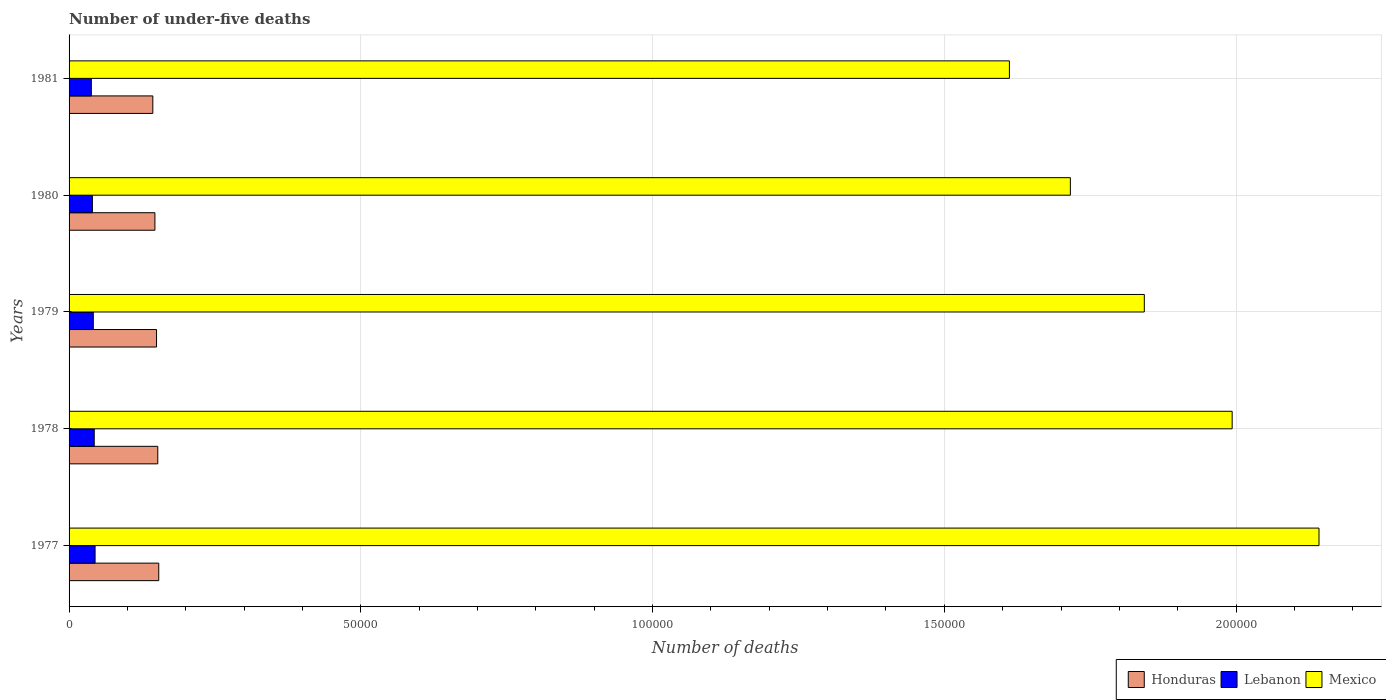How many groups of bars are there?
Your answer should be very brief. 5. Are the number of bars on each tick of the Y-axis equal?
Keep it short and to the point. Yes. How many bars are there on the 4th tick from the top?
Your answer should be compact. 3. In how many cases, is the number of bars for a given year not equal to the number of legend labels?
Offer a very short reply. 0. What is the number of under-five deaths in Lebanon in 1978?
Ensure brevity in your answer.  4313. Across all years, what is the maximum number of under-five deaths in Lebanon?
Keep it short and to the point. 4458. Across all years, what is the minimum number of under-five deaths in Lebanon?
Offer a very short reply. 3815. In which year was the number of under-five deaths in Mexico maximum?
Ensure brevity in your answer.  1977. In which year was the number of under-five deaths in Mexico minimum?
Offer a terse response. 1981. What is the total number of under-five deaths in Mexico in the graph?
Provide a succinct answer. 9.31e+05. What is the difference between the number of under-five deaths in Honduras in 1978 and that in 1980?
Provide a succinct answer. 490. What is the difference between the number of under-five deaths in Mexico in 1980 and the number of under-five deaths in Lebanon in 1979?
Your response must be concise. 1.67e+05. What is the average number of under-five deaths in Honduras per year?
Ensure brevity in your answer.  1.49e+04. In the year 1977, what is the difference between the number of under-five deaths in Lebanon and number of under-five deaths in Honduras?
Provide a short and direct response. -1.09e+04. What is the ratio of the number of under-five deaths in Lebanon in 1978 to that in 1979?
Ensure brevity in your answer.  1.04. Is the number of under-five deaths in Mexico in 1978 less than that in 1979?
Your answer should be very brief. No. Is the difference between the number of under-five deaths in Lebanon in 1978 and 1979 greater than the difference between the number of under-five deaths in Honduras in 1978 and 1979?
Offer a very short reply. No. What is the difference between the highest and the second highest number of under-five deaths in Lebanon?
Provide a succinct answer. 145. What is the difference between the highest and the lowest number of under-five deaths in Mexico?
Your answer should be very brief. 5.31e+04. In how many years, is the number of under-five deaths in Lebanon greater than the average number of under-five deaths in Lebanon taken over all years?
Your response must be concise. 3. Is the sum of the number of under-five deaths in Honduras in 1977 and 1978 greater than the maximum number of under-five deaths in Lebanon across all years?
Your answer should be compact. Yes. What does the 3rd bar from the top in 1979 represents?
Your answer should be very brief. Honduras. How many bars are there?
Ensure brevity in your answer.  15. Are all the bars in the graph horizontal?
Offer a very short reply. Yes. How many years are there in the graph?
Provide a succinct answer. 5. What is the difference between two consecutive major ticks on the X-axis?
Your answer should be compact. 5.00e+04. Does the graph contain any zero values?
Make the answer very short. No. Does the graph contain grids?
Keep it short and to the point. Yes. How many legend labels are there?
Your answer should be very brief. 3. What is the title of the graph?
Offer a terse response. Number of under-five deaths. What is the label or title of the X-axis?
Keep it short and to the point. Number of deaths. What is the Number of deaths of Honduras in 1977?
Your answer should be very brief. 1.54e+04. What is the Number of deaths of Lebanon in 1977?
Provide a short and direct response. 4458. What is the Number of deaths of Mexico in 1977?
Offer a terse response. 2.14e+05. What is the Number of deaths in Honduras in 1978?
Provide a succinct answer. 1.52e+04. What is the Number of deaths of Lebanon in 1978?
Your answer should be compact. 4313. What is the Number of deaths of Mexico in 1978?
Your answer should be compact. 1.99e+05. What is the Number of deaths of Honduras in 1979?
Keep it short and to the point. 1.50e+04. What is the Number of deaths in Lebanon in 1979?
Your response must be concise. 4152. What is the Number of deaths in Mexico in 1979?
Your answer should be very brief. 1.84e+05. What is the Number of deaths of Honduras in 1980?
Provide a succinct answer. 1.47e+04. What is the Number of deaths in Lebanon in 1980?
Offer a terse response. 3993. What is the Number of deaths of Mexico in 1980?
Ensure brevity in your answer.  1.72e+05. What is the Number of deaths in Honduras in 1981?
Offer a terse response. 1.44e+04. What is the Number of deaths in Lebanon in 1981?
Make the answer very short. 3815. What is the Number of deaths of Mexico in 1981?
Your answer should be compact. 1.61e+05. Across all years, what is the maximum Number of deaths in Honduras?
Provide a succinct answer. 1.54e+04. Across all years, what is the maximum Number of deaths of Lebanon?
Ensure brevity in your answer.  4458. Across all years, what is the maximum Number of deaths of Mexico?
Ensure brevity in your answer.  2.14e+05. Across all years, what is the minimum Number of deaths of Honduras?
Give a very brief answer. 1.44e+04. Across all years, what is the minimum Number of deaths in Lebanon?
Give a very brief answer. 3815. Across all years, what is the minimum Number of deaths of Mexico?
Provide a succinct answer. 1.61e+05. What is the total Number of deaths in Honduras in the graph?
Offer a terse response. 7.46e+04. What is the total Number of deaths of Lebanon in the graph?
Your answer should be compact. 2.07e+04. What is the total Number of deaths in Mexico in the graph?
Your answer should be compact. 9.31e+05. What is the difference between the Number of deaths in Honduras in 1977 and that in 1978?
Offer a very short reply. 168. What is the difference between the Number of deaths of Lebanon in 1977 and that in 1978?
Keep it short and to the point. 145. What is the difference between the Number of deaths of Mexico in 1977 and that in 1978?
Your answer should be compact. 1.49e+04. What is the difference between the Number of deaths in Honduras in 1977 and that in 1979?
Make the answer very short. 379. What is the difference between the Number of deaths of Lebanon in 1977 and that in 1979?
Your answer should be very brief. 306. What is the difference between the Number of deaths in Mexico in 1977 and that in 1979?
Your response must be concise. 2.99e+04. What is the difference between the Number of deaths of Honduras in 1977 and that in 1980?
Offer a very short reply. 658. What is the difference between the Number of deaths in Lebanon in 1977 and that in 1980?
Offer a very short reply. 465. What is the difference between the Number of deaths in Mexico in 1977 and that in 1980?
Give a very brief answer. 4.26e+04. What is the difference between the Number of deaths in Honduras in 1977 and that in 1981?
Keep it short and to the point. 1016. What is the difference between the Number of deaths in Lebanon in 1977 and that in 1981?
Give a very brief answer. 643. What is the difference between the Number of deaths of Mexico in 1977 and that in 1981?
Your answer should be compact. 5.31e+04. What is the difference between the Number of deaths in Honduras in 1978 and that in 1979?
Your answer should be compact. 211. What is the difference between the Number of deaths of Lebanon in 1978 and that in 1979?
Your answer should be very brief. 161. What is the difference between the Number of deaths in Mexico in 1978 and that in 1979?
Keep it short and to the point. 1.51e+04. What is the difference between the Number of deaths of Honduras in 1978 and that in 1980?
Provide a short and direct response. 490. What is the difference between the Number of deaths in Lebanon in 1978 and that in 1980?
Offer a very short reply. 320. What is the difference between the Number of deaths of Mexico in 1978 and that in 1980?
Provide a short and direct response. 2.77e+04. What is the difference between the Number of deaths in Honduras in 1978 and that in 1981?
Offer a very short reply. 848. What is the difference between the Number of deaths of Lebanon in 1978 and that in 1981?
Offer a very short reply. 498. What is the difference between the Number of deaths of Mexico in 1978 and that in 1981?
Your response must be concise. 3.82e+04. What is the difference between the Number of deaths in Honduras in 1979 and that in 1980?
Your answer should be very brief. 279. What is the difference between the Number of deaths in Lebanon in 1979 and that in 1980?
Your answer should be very brief. 159. What is the difference between the Number of deaths in Mexico in 1979 and that in 1980?
Offer a terse response. 1.27e+04. What is the difference between the Number of deaths in Honduras in 1979 and that in 1981?
Ensure brevity in your answer.  637. What is the difference between the Number of deaths of Lebanon in 1979 and that in 1981?
Give a very brief answer. 337. What is the difference between the Number of deaths of Mexico in 1979 and that in 1981?
Offer a very short reply. 2.31e+04. What is the difference between the Number of deaths in Honduras in 1980 and that in 1981?
Offer a very short reply. 358. What is the difference between the Number of deaths in Lebanon in 1980 and that in 1981?
Keep it short and to the point. 178. What is the difference between the Number of deaths in Mexico in 1980 and that in 1981?
Keep it short and to the point. 1.04e+04. What is the difference between the Number of deaths of Honduras in 1977 and the Number of deaths of Lebanon in 1978?
Offer a very short reply. 1.11e+04. What is the difference between the Number of deaths of Honduras in 1977 and the Number of deaths of Mexico in 1978?
Provide a succinct answer. -1.84e+05. What is the difference between the Number of deaths of Lebanon in 1977 and the Number of deaths of Mexico in 1978?
Make the answer very short. -1.95e+05. What is the difference between the Number of deaths in Honduras in 1977 and the Number of deaths in Lebanon in 1979?
Make the answer very short. 1.12e+04. What is the difference between the Number of deaths of Honduras in 1977 and the Number of deaths of Mexico in 1979?
Offer a terse response. -1.69e+05. What is the difference between the Number of deaths in Lebanon in 1977 and the Number of deaths in Mexico in 1979?
Provide a short and direct response. -1.80e+05. What is the difference between the Number of deaths in Honduras in 1977 and the Number of deaths in Lebanon in 1980?
Offer a terse response. 1.14e+04. What is the difference between the Number of deaths in Honduras in 1977 and the Number of deaths in Mexico in 1980?
Make the answer very short. -1.56e+05. What is the difference between the Number of deaths in Lebanon in 1977 and the Number of deaths in Mexico in 1980?
Provide a succinct answer. -1.67e+05. What is the difference between the Number of deaths of Honduras in 1977 and the Number of deaths of Lebanon in 1981?
Offer a very short reply. 1.16e+04. What is the difference between the Number of deaths in Honduras in 1977 and the Number of deaths in Mexico in 1981?
Keep it short and to the point. -1.46e+05. What is the difference between the Number of deaths of Lebanon in 1977 and the Number of deaths of Mexico in 1981?
Your response must be concise. -1.57e+05. What is the difference between the Number of deaths in Honduras in 1978 and the Number of deaths in Lebanon in 1979?
Your answer should be very brief. 1.10e+04. What is the difference between the Number of deaths of Honduras in 1978 and the Number of deaths of Mexico in 1979?
Keep it short and to the point. -1.69e+05. What is the difference between the Number of deaths in Lebanon in 1978 and the Number of deaths in Mexico in 1979?
Ensure brevity in your answer.  -1.80e+05. What is the difference between the Number of deaths in Honduras in 1978 and the Number of deaths in Lebanon in 1980?
Make the answer very short. 1.12e+04. What is the difference between the Number of deaths of Honduras in 1978 and the Number of deaths of Mexico in 1980?
Offer a very short reply. -1.56e+05. What is the difference between the Number of deaths in Lebanon in 1978 and the Number of deaths in Mexico in 1980?
Your answer should be compact. -1.67e+05. What is the difference between the Number of deaths in Honduras in 1978 and the Number of deaths in Lebanon in 1981?
Make the answer very short. 1.14e+04. What is the difference between the Number of deaths in Honduras in 1978 and the Number of deaths in Mexico in 1981?
Your answer should be very brief. -1.46e+05. What is the difference between the Number of deaths of Lebanon in 1978 and the Number of deaths of Mexico in 1981?
Keep it short and to the point. -1.57e+05. What is the difference between the Number of deaths of Honduras in 1979 and the Number of deaths of Lebanon in 1980?
Give a very brief answer. 1.10e+04. What is the difference between the Number of deaths in Honduras in 1979 and the Number of deaths in Mexico in 1980?
Offer a very short reply. -1.57e+05. What is the difference between the Number of deaths of Lebanon in 1979 and the Number of deaths of Mexico in 1980?
Give a very brief answer. -1.67e+05. What is the difference between the Number of deaths of Honduras in 1979 and the Number of deaths of Lebanon in 1981?
Give a very brief answer. 1.12e+04. What is the difference between the Number of deaths in Honduras in 1979 and the Number of deaths in Mexico in 1981?
Make the answer very short. -1.46e+05. What is the difference between the Number of deaths in Lebanon in 1979 and the Number of deaths in Mexico in 1981?
Give a very brief answer. -1.57e+05. What is the difference between the Number of deaths in Honduras in 1980 and the Number of deaths in Lebanon in 1981?
Provide a short and direct response. 1.09e+04. What is the difference between the Number of deaths of Honduras in 1980 and the Number of deaths of Mexico in 1981?
Your response must be concise. -1.46e+05. What is the difference between the Number of deaths in Lebanon in 1980 and the Number of deaths in Mexico in 1981?
Provide a short and direct response. -1.57e+05. What is the average Number of deaths of Honduras per year?
Your response must be concise. 1.49e+04. What is the average Number of deaths of Lebanon per year?
Offer a terse response. 4146.2. What is the average Number of deaths in Mexico per year?
Your answer should be very brief. 1.86e+05. In the year 1977, what is the difference between the Number of deaths in Honduras and Number of deaths in Lebanon?
Keep it short and to the point. 1.09e+04. In the year 1977, what is the difference between the Number of deaths of Honduras and Number of deaths of Mexico?
Make the answer very short. -1.99e+05. In the year 1977, what is the difference between the Number of deaths of Lebanon and Number of deaths of Mexico?
Your response must be concise. -2.10e+05. In the year 1978, what is the difference between the Number of deaths in Honduras and Number of deaths in Lebanon?
Your response must be concise. 1.09e+04. In the year 1978, what is the difference between the Number of deaths of Honduras and Number of deaths of Mexico?
Offer a terse response. -1.84e+05. In the year 1978, what is the difference between the Number of deaths in Lebanon and Number of deaths in Mexico?
Offer a terse response. -1.95e+05. In the year 1979, what is the difference between the Number of deaths in Honduras and Number of deaths in Lebanon?
Provide a succinct answer. 1.08e+04. In the year 1979, what is the difference between the Number of deaths in Honduras and Number of deaths in Mexico?
Provide a succinct answer. -1.69e+05. In the year 1979, what is the difference between the Number of deaths in Lebanon and Number of deaths in Mexico?
Ensure brevity in your answer.  -1.80e+05. In the year 1980, what is the difference between the Number of deaths of Honduras and Number of deaths of Lebanon?
Your answer should be compact. 1.07e+04. In the year 1980, what is the difference between the Number of deaths in Honduras and Number of deaths in Mexico?
Ensure brevity in your answer.  -1.57e+05. In the year 1980, what is the difference between the Number of deaths in Lebanon and Number of deaths in Mexico?
Keep it short and to the point. -1.68e+05. In the year 1981, what is the difference between the Number of deaths of Honduras and Number of deaths of Lebanon?
Your answer should be compact. 1.05e+04. In the year 1981, what is the difference between the Number of deaths in Honduras and Number of deaths in Mexico?
Your answer should be very brief. -1.47e+05. In the year 1981, what is the difference between the Number of deaths in Lebanon and Number of deaths in Mexico?
Ensure brevity in your answer.  -1.57e+05. What is the ratio of the Number of deaths of Honduras in 1977 to that in 1978?
Provide a short and direct response. 1.01. What is the ratio of the Number of deaths of Lebanon in 1977 to that in 1978?
Your response must be concise. 1.03. What is the ratio of the Number of deaths of Mexico in 1977 to that in 1978?
Keep it short and to the point. 1.07. What is the ratio of the Number of deaths in Honduras in 1977 to that in 1979?
Offer a terse response. 1.03. What is the ratio of the Number of deaths of Lebanon in 1977 to that in 1979?
Make the answer very short. 1.07. What is the ratio of the Number of deaths in Mexico in 1977 to that in 1979?
Your answer should be compact. 1.16. What is the ratio of the Number of deaths of Honduras in 1977 to that in 1980?
Make the answer very short. 1.04. What is the ratio of the Number of deaths in Lebanon in 1977 to that in 1980?
Provide a short and direct response. 1.12. What is the ratio of the Number of deaths in Mexico in 1977 to that in 1980?
Offer a very short reply. 1.25. What is the ratio of the Number of deaths of Honduras in 1977 to that in 1981?
Your response must be concise. 1.07. What is the ratio of the Number of deaths of Lebanon in 1977 to that in 1981?
Keep it short and to the point. 1.17. What is the ratio of the Number of deaths of Mexico in 1977 to that in 1981?
Make the answer very short. 1.33. What is the ratio of the Number of deaths in Honduras in 1978 to that in 1979?
Offer a terse response. 1.01. What is the ratio of the Number of deaths in Lebanon in 1978 to that in 1979?
Make the answer very short. 1.04. What is the ratio of the Number of deaths of Mexico in 1978 to that in 1979?
Ensure brevity in your answer.  1.08. What is the ratio of the Number of deaths of Honduras in 1978 to that in 1980?
Ensure brevity in your answer.  1.03. What is the ratio of the Number of deaths of Lebanon in 1978 to that in 1980?
Make the answer very short. 1.08. What is the ratio of the Number of deaths in Mexico in 1978 to that in 1980?
Keep it short and to the point. 1.16. What is the ratio of the Number of deaths of Honduras in 1978 to that in 1981?
Make the answer very short. 1.06. What is the ratio of the Number of deaths in Lebanon in 1978 to that in 1981?
Your response must be concise. 1.13. What is the ratio of the Number of deaths in Mexico in 1978 to that in 1981?
Your answer should be very brief. 1.24. What is the ratio of the Number of deaths in Honduras in 1979 to that in 1980?
Offer a very short reply. 1.02. What is the ratio of the Number of deaths in Lebanon in 1979 to that in 1980?
Ensure brevity in your answer.  1.04. What is the ratio of the Number of deaths of Mexico in 1979 to that in 1980?
Offer a very short reply. 1.07. What is the ratio of the Number of deaths in Honduras in 1979 to that in 1981?
Keep it short and to the point. 1.04. What is the ratio of the Number of deaths of Lebanon in 1979 to that in 1981?
Provide a short and direct response. 1.09. What is the ratio of the Number of deaths in Mexico in 1979 to that in 1981?
Offer a very short reply. 1.14. What is the ratio of the Number of deaths of Honduras in 1980 to that in 1981?
Ensure brevity in your answer.  1.02. What is the ratio of the Number of deaths in Lebanon in 1980 to that in 1981?
Ensure brevity in your answer.  1.05. What is the ratio of the Number of deaths in Mexico in 1980 to that in 1981?
Your answer should be very brief. 1.06. What is the difference between the highest and the second highest Number of deaths of Honduras?
Ensure brevity in your answer.  168. What is the difference between the highest and the second highest Number of deaths of Lebanon?
Offer a terse response. 145. What is the difference between the highest and the second highest Number of deaths in Mexico?
Offer a terse response. 1.49e+04. What is the difference between the highest and the lowest Number of deaths in Honduras?
Your answer should be compact. 1016. What is the difference between the highest and the lowest Number of deaths in Lebanon?
Offer a terse response. 643. What is the difference between the highest and the lowest Number of deaths in Mexico?
Provide a short and direct response. 5.31e+04. 